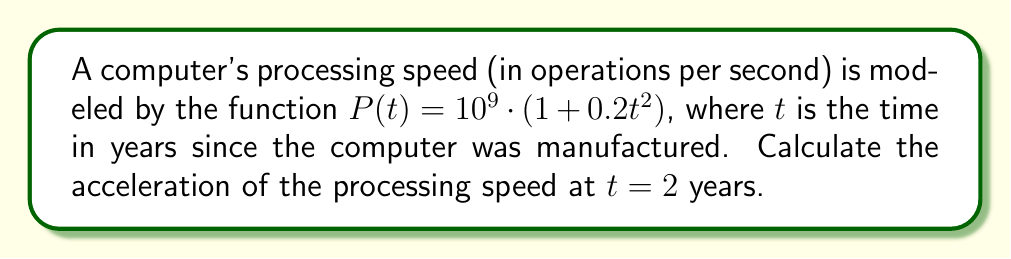Provide a solution to this math problem. To find the acceleration of the processing speed, we need to calculate the second derivative of $P(t)$ and evaluate it at $t = 2$.

Step 1: Find the first derivative $P'(t)$
$$P'(t) = \frac{d}{dt}[10^9 \cdot (1 + 0.2t^2)]$$
$$P'(t) = 10^9 \cdot \frac{d}{dt}[1 + 0.2t^2]$$
$$P'(t) = 10^9 \cdot 0.4t$$
$$P'(t) = 4 \times 10^8 t$$

Step 2: Find the second derivative $P''(t)$
$$P''(t) = \frac{d}{dt}[4 \times 10^8 t]$$
$$P''(t) = 4 \times 10^8$$

Step 3: Evaluate $P''(t)$ at $t = 2$
Since $P''(t)$ is constant, its value is the same for all $t$, including $t = 2$:

$$P''(2) = 4 \times 10^8$$

This value represents the acceleration of the processing speed in operations per second per year squared.
Answer: $4 \times 10^8$ ops/s/year² 